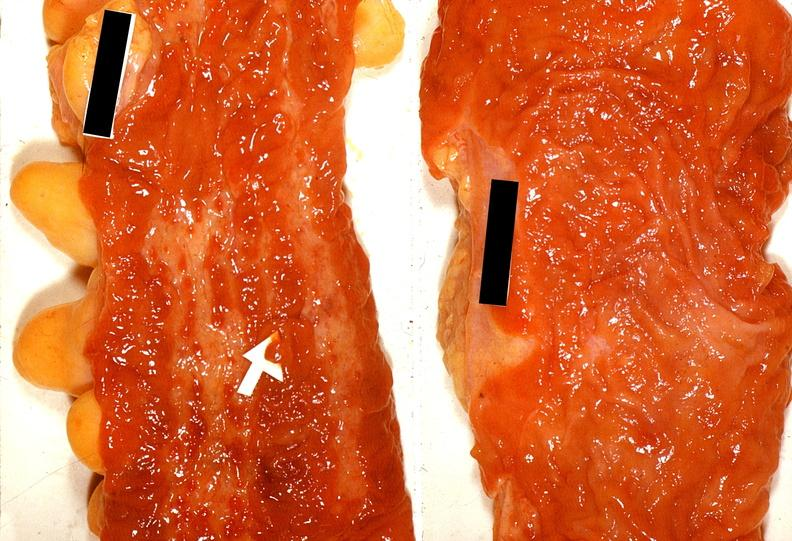s 70yof present?
Answer the question using a single word or phrase. No 